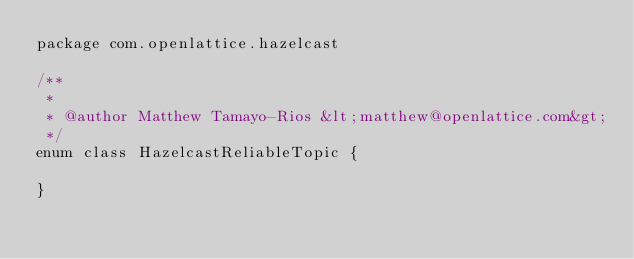Convert code to text. <code><loc_0><loc_0><loc_500><loc_500><_Kotlin_>package com.openlattice.hazelcast

/**
 *
 * @author Matthew Tamayo-Rios &lt;matthew@openlattice.com&gt;
 */
enum class HazelcastReliableTopic {

}</code> 